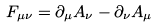<formula> <loc_0><loc_0><loc_500><loc_500>F _ { \mu \nu } = \partial _ { \mu } A _ { \nu } - \partial _ { \nu } A _ { \mu }</formula> 